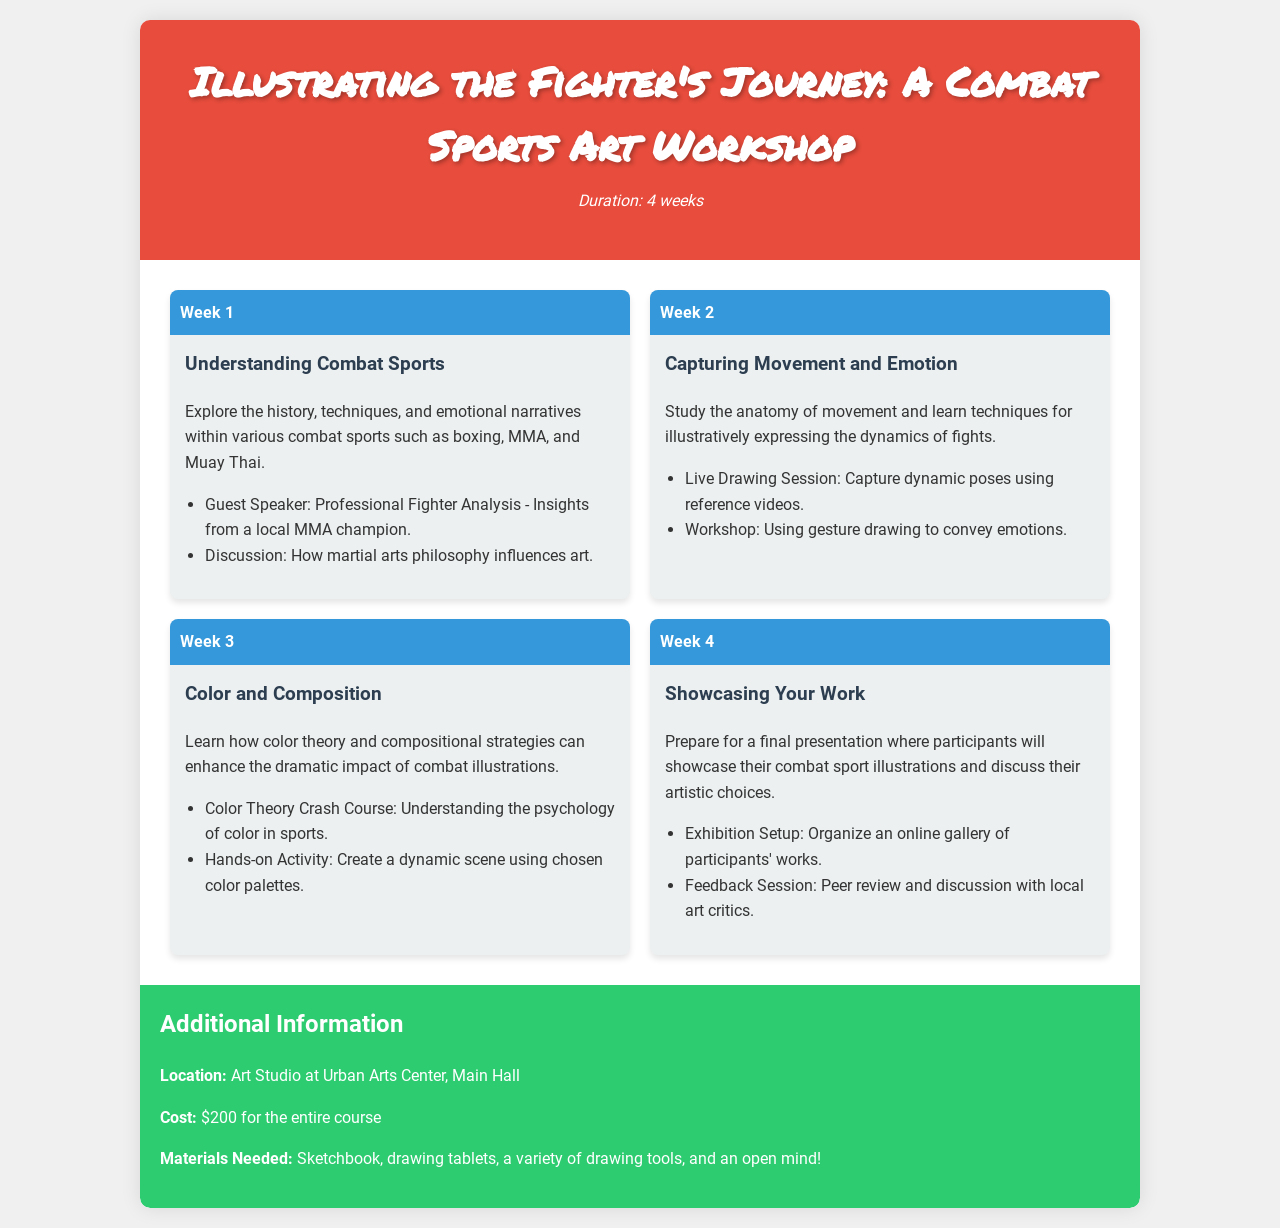What is the duration of the workshop? The workshop is designed to last for four weeks, which is stated in the header.
Answer: 4 weeks What is the location of the workshop? The location is mentioned in the additional information section of the document.
Answer: Art Studio at Urban Arts Center, Main Hall What is the cost of the entire course? The cost is specified in the additional information section of the document.
Answer: $200 What is the main focus of Week 2? The main focus for Week 2 is highlighted in the week content section of the document.
Answer: Capturing Movement and Emotion Who is the guest speaker in Week 1? The guest speaker's details are listed under Week 1's content.
Answer: Professional Fighter Analysis What activity is scheduled for Week 3? The activity for Week 3 is outlined in the week content section.
Answer: Create a dynamic scene using chosen color palettes What type of drawing is emphasized in Week 2? The document specifies the type of drawing emphasized during Week 2.
Answer: Gesture drawing How will participants showcase their work in Week 4? The method of showcasing work is described in Week 4's content.
Answer: Online gallery of participants' works What is required to participate in the course? The required materials are detailed in the additional information section.
Answer: Sketchbook, drawing tablets, a variety of drawing tools, and an open mind! 